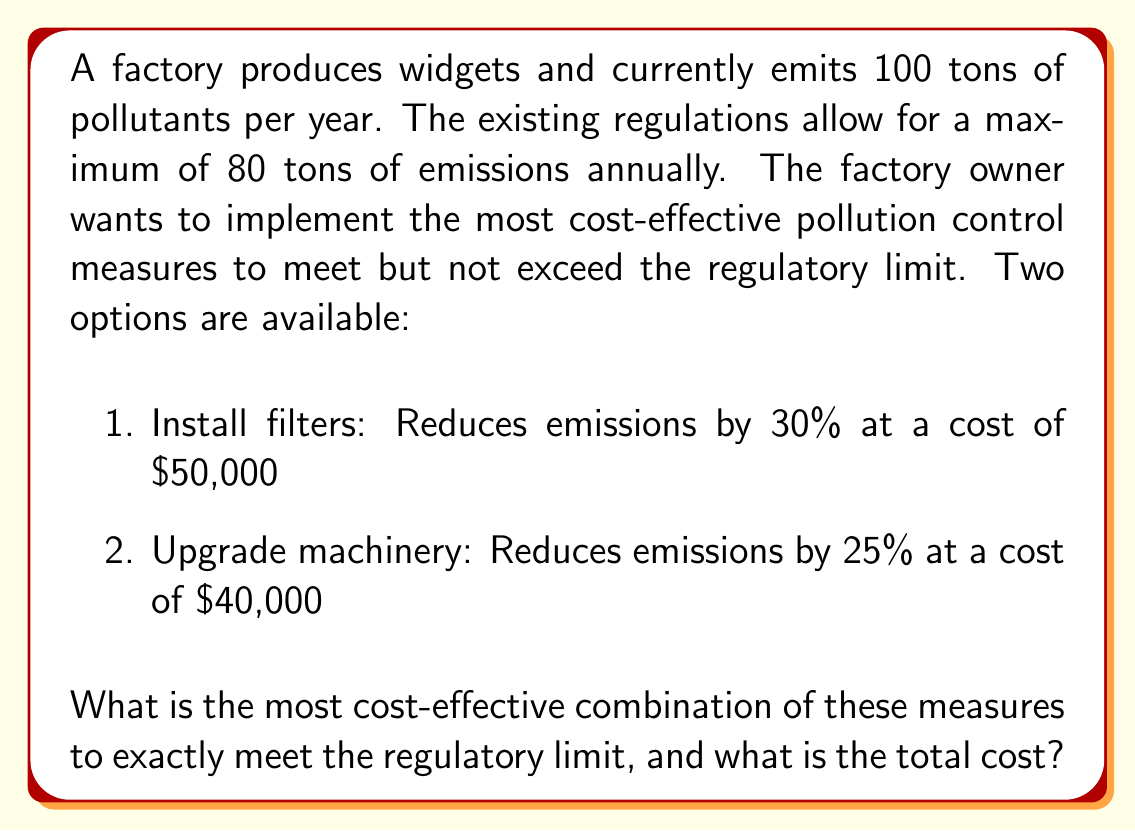Provide a solution to this math problem. Let's approach this step-by-step:

1) First, we need to calculate how much reduction in emissions is required:
   Required reduction = Current emissions - Regulatory limit
   $$ 100 - 80 = 20 \text{ tons} $$

2) Now, let's express the reduction from each option as variables:
   Let $x$ be the number of filter installations
   Let $y$ be the number of machinery upgrades

3) We can set up an equation based on the reduction needed:
   $$ 30x + 25y = 20 $$
   Where 30 represents the 30% (or 30 ton) reduction from filters, and 25 represents the 25% (or 25 ton) reduction from upgrades.

4) We need to minimize the cost, which can be expressed as:
   $$ \text{Total Cost} = 50000x + 40000y $$

5) Given that $x$ and $y$ must be non-negative integers, we can try different combinations:

   If $x = 0$ and $y = 0.8$, but $y$ must be an integer, so this doesn't work.
   If $x = 1$, then $30 + 25y = 20$, so $y = -0.4$, which is not possible.
   If $y = 1$, then $30x + 25 = 20$, so $x = -1/6$, which is not possible.

6) The only remaining possibility is to use both measures once:
   If $x = 1$ and $y = 1$, then $30(1) + 25(1) = 55$, which exceeds our needed reduction but meets the regulatory limit exactly.

7) The total cost with this combination is:
   $$ 50000(1) + 40000(1) = 90000 $$

This is the only integer solution that meets the regulatory limit exactly, and is therefore the most cost-effective.
Answer: The most cost-effective combination is to install one set of filters and upgrade the machinery once. The total cost is $90,000. 